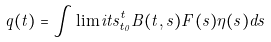<formula> <loc_0><loc_0><loc_500><loc_500>q ( t ) = \int \lim i t s _ { t _ { 0 } } ^ { t } B ( t , s ) F ( s ) \eta ( s ) d s</formula> 